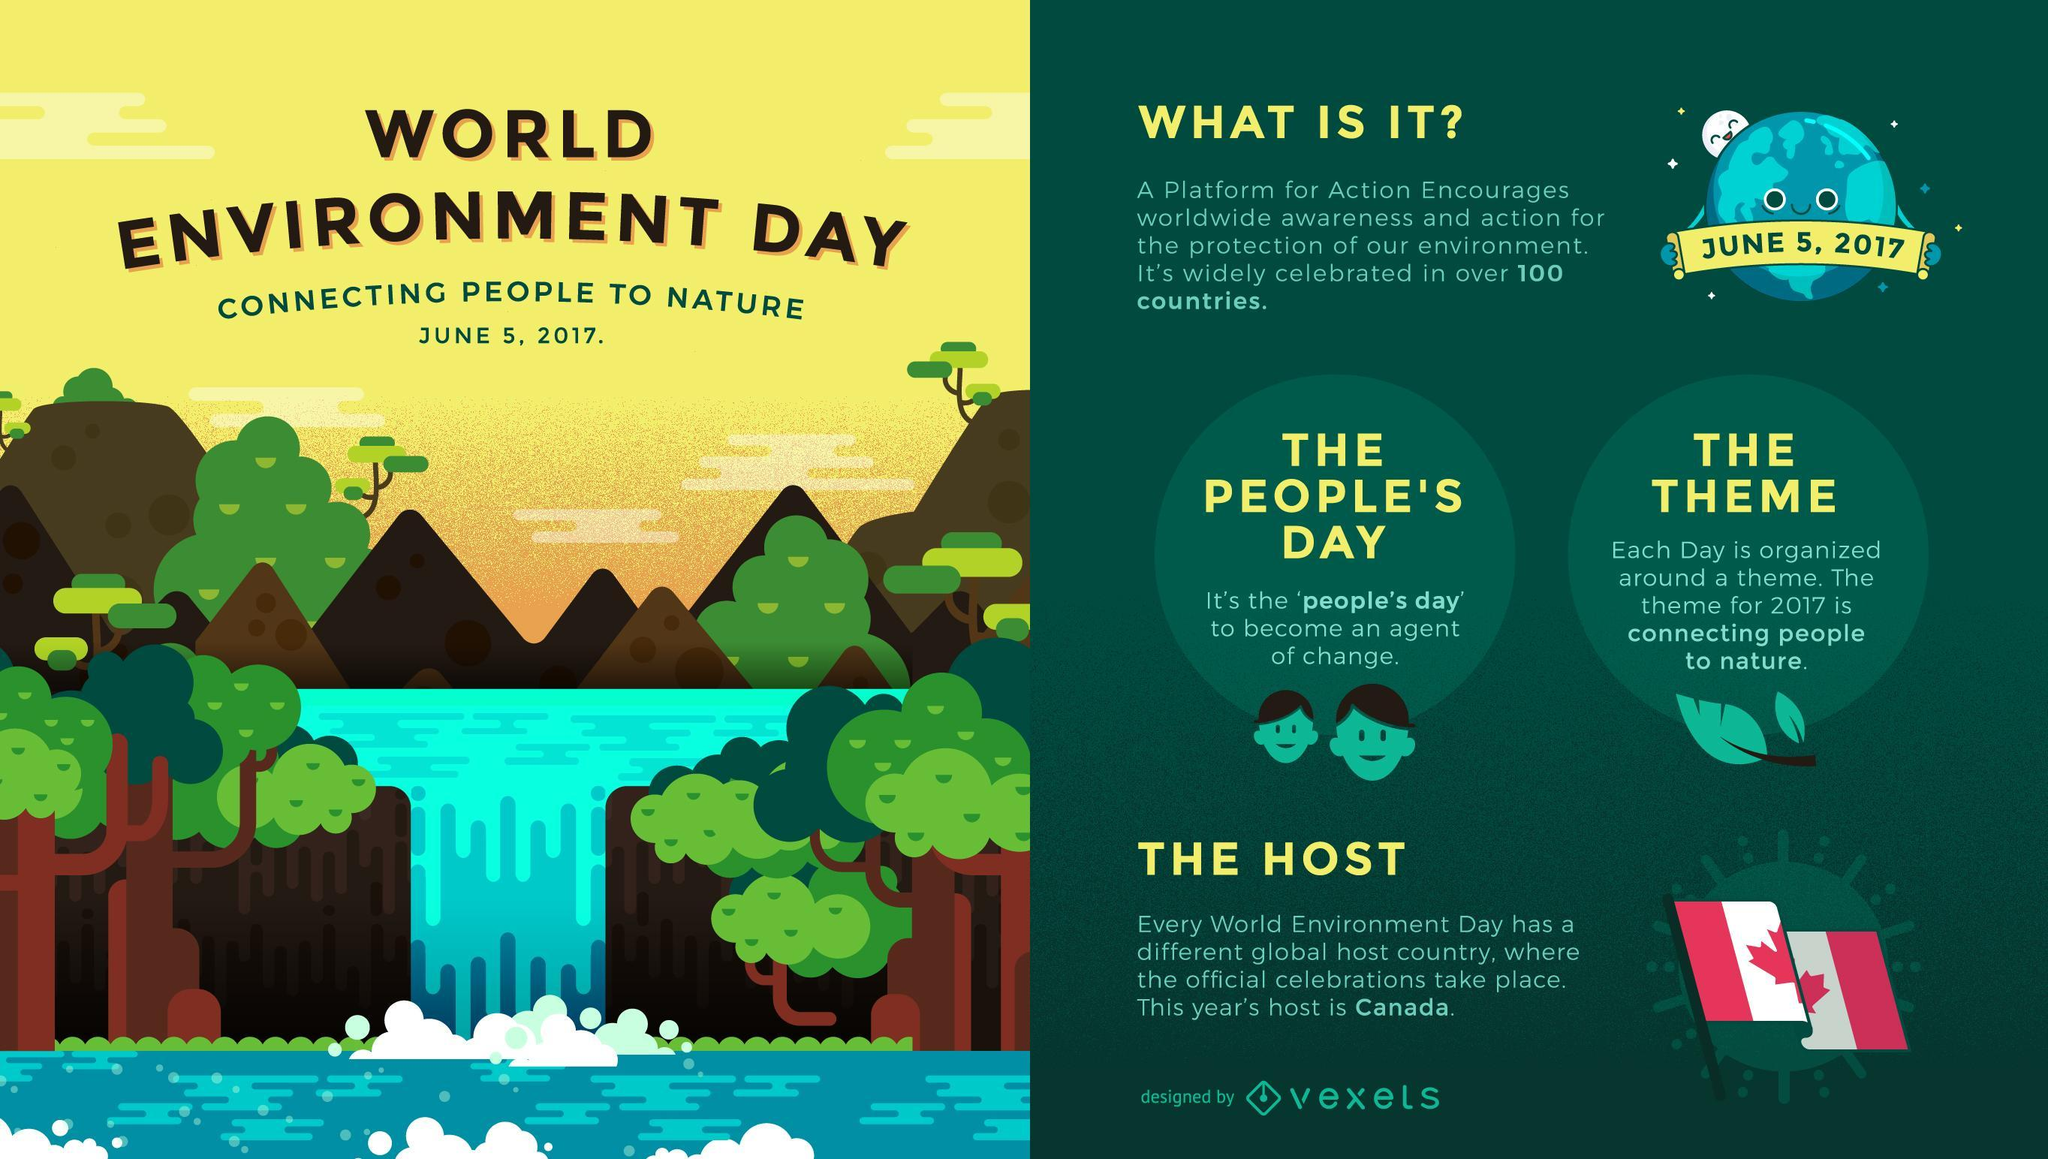How many points are under the Main heading?
Answer the question with a short phrase. 4 How many flags are in this infographic? 1 